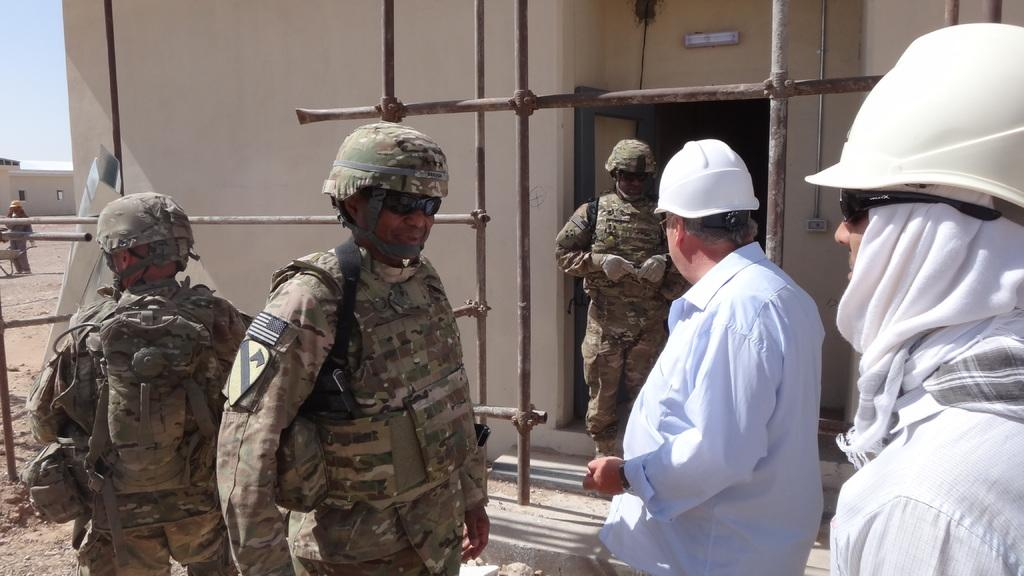What can be seen in the image? There are men standing in the image. What are the men wearing on their heads? The men are wearing helmets. What type of eyewear are the men wearing? The men are wearing sunglasses. What can be seen in the background of the image? There is a wall of a house in the background. What part of the sky is visible in the image? The sky is visible in the top left of the image. How many stockings are hanging on the wall in the image? There are no stockings visible in the image; the men are wearing helmets and sunglasses, and the background features a wall of a house. What type of ticket can be seen in the hands of the men in the image? There are no tickets present in the image; the men are wearing helmets and sunglasses, and there is no indication of any tickets or related items. 